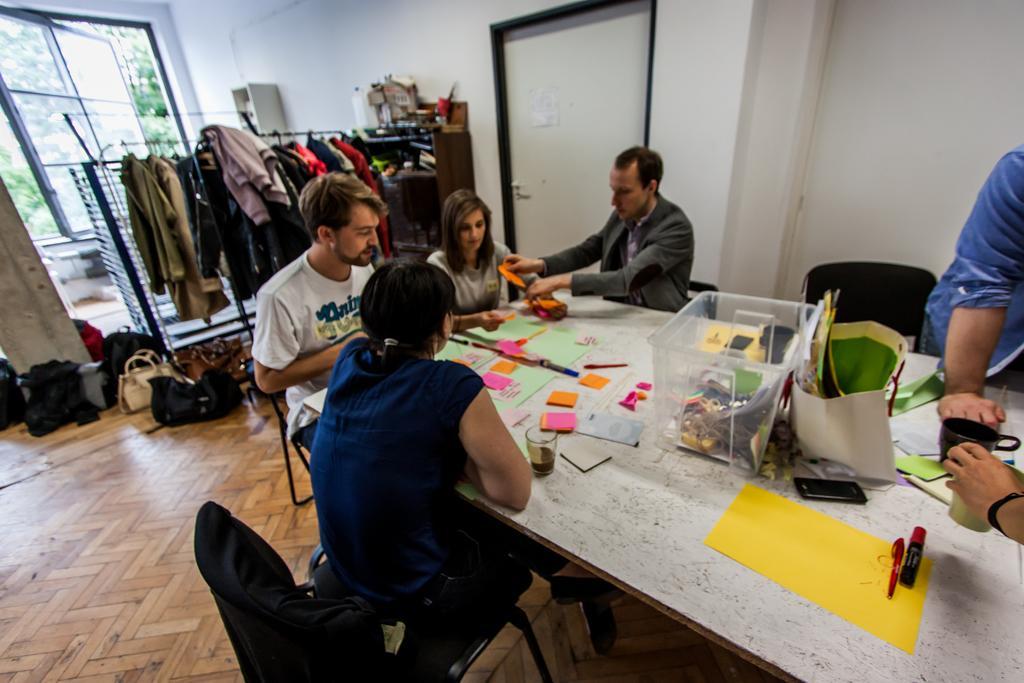Can you describe this image briefly? An indoor picture. Suits are hanging to this rod. This persons are sitting around this table, on this table there is a container, glass, papers, marker, cup and notes. This person wore suit and holding a note. On floor there are bags. From this window we can able to see trees. At the corner of the image a person is standing and holding a cup. This is door with handle. This rack is filled with things and books. 